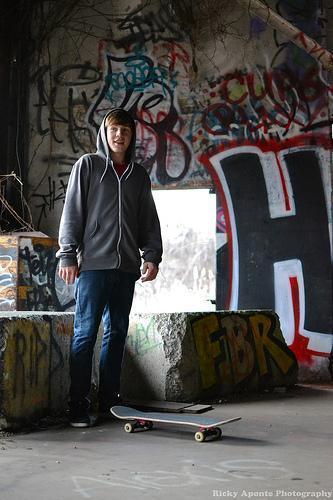How many skateboards are in the picture?
Give a very brief answer. 1. 